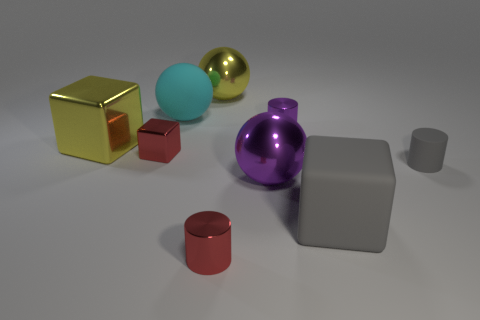Subtract all purple balls. How many balls are left? 2 Add 1 large gray matte things. How many objects exist? 10 Subtract all yellow blocks. How many blocks are left? 2 Subtract all cubes. How many objects are left? 6 Subtract 1 cylinders. How many cylinders are left? 2 Add 1 small gray cylinders. How many small gray cylinders are left? 2 Add 7 big yellow cylinders. How many big yellow cylinders exist? 7 Subtract 0 brown cylinders. How many objects are left? 9 Subtract all green spheres. Subtract all cyan blocks. How many spheres are left? 3 Subtract all brown cubes. How many cyan spheres are left? 1 